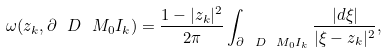Convert formula to latex. <formula><loc_0><loc_0><loc_500><loc_500>\omega ( z _ { k } , \partial \ D \ M _ { 0 } I _ { k } ) = \frac { 1 - | z _ { k } | ^ { 2 } } { 2 \pi } \int _ { \partial \ D \ M _ { 0 } I _ { k } } \frac { | d \xi | } { | \xi - z _ { k } | ^ { 2 } } ,</formula> 